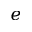<formula> <loc_0><loc_0><loc_500><loc_500>e</formula> 